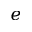<formula> <loc_0><loc_0><loc_500><loc_500>e</formula> 